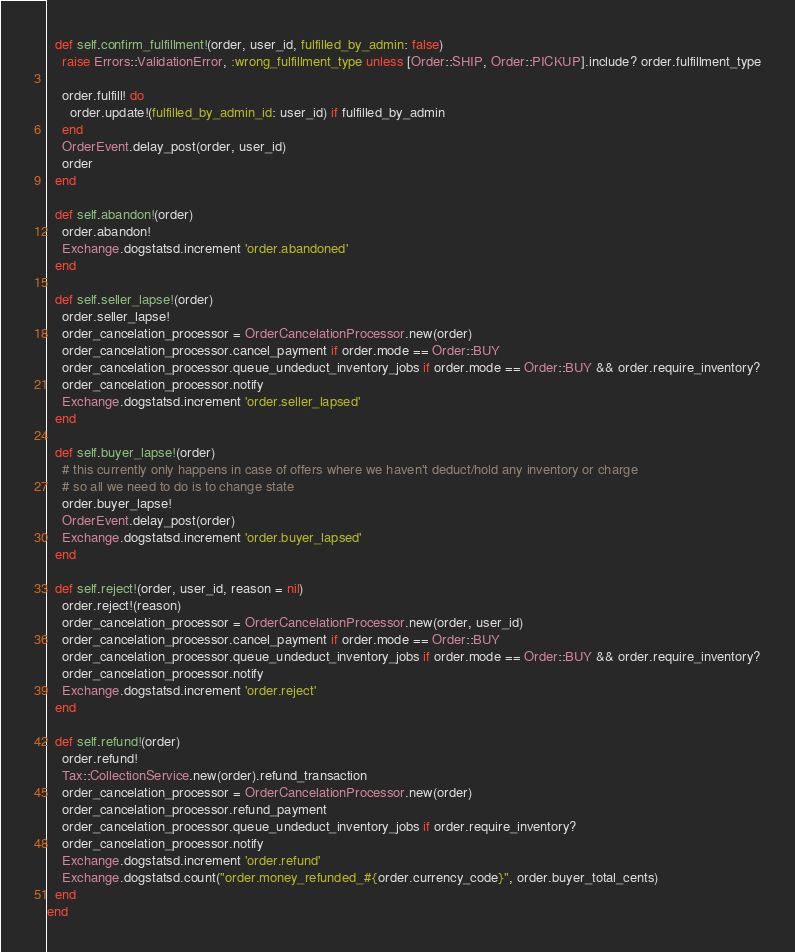Convert code to text. <code><loc_0><loc_0><loc_500><loc_500><_Ruby_>
  def self.confirm_fulfillment!(order, user_id, fulfilled_by_admin: false)
    raise Errors::ValidationError, :wrong_fulfillment_type unless [Order::SHIP, Order::PICKUP].include? order.fulfillment_type

    order.fulfill! do
      order.update!(fulfilled_by_admin_id: user_id) if fulfilled_by_admin
    end
    OrderEvent.delay_post(order, user_id)
    order
  end

  def self.abandon!(order)
    order.abandon!
    Exchange.dogstatsd.increment 'order.abandoned'
  end

  def self.seller_lapse!(order)
    order.seller_lapse!
    order_cancelation_processor = OrderCancelationProcessor.new(order)
    order_cancelation_processor.cancel_payment if order.mode == Order::BUY
    order_cancelation_processor.queue_undeduct_inventory_jobs if order.mode == Order::BUY && order.require_inventory?
    order_cancelation_processor.notify
    Exchange.dogstatsd.increment 'order.seller_lapsed'
  end

  def self.buyer_lapse!(order)
    # this currently only happens in case of offers where we haven't deduct/hold any inventory or charge
    # so all we need to do is to change state
    order.buyer_lapse!
    OrderEvent.delay_post(order)
    Exchange.dogstatsd.increment 'order.buyer_lapsed'
  end

  def self.reject!(order, user_id, reason = nil)
    order.reject!(reason)
    order_cancelation_processor = OrderCancelationProcessor.new(order, user_id)
    order_cancelation_processor.cancel_payment if order.mode == Order::BUY
    order_cancelation_processor.queue_undeduct_inventory_jobs if order.mode == Order::BUY && order.require_inventory?
    order_cancelation_processor.notify
    Exchange.dogstatsd.increment 'order.reject'
  end

  def self.refund!(order)
    order.refund!
    Tax::CollectionService.new(order).refund_transaction
    order_cancelation_processor = OrderCancelationProcessor.new(order)
    order_cancelation_processor.refund_payment
    order_cancelation_processor.queue_undeduct_inventory_jobs if order.require_inventory?
    order_cancelation_processor.notify
    Exchange.dogstatsd.increment 'order.refund'
    Exchange.dogstatsd.count("order.money_refunded_#{order.currency_code}", order.buyer_total_cents)
  end
end
</code> 